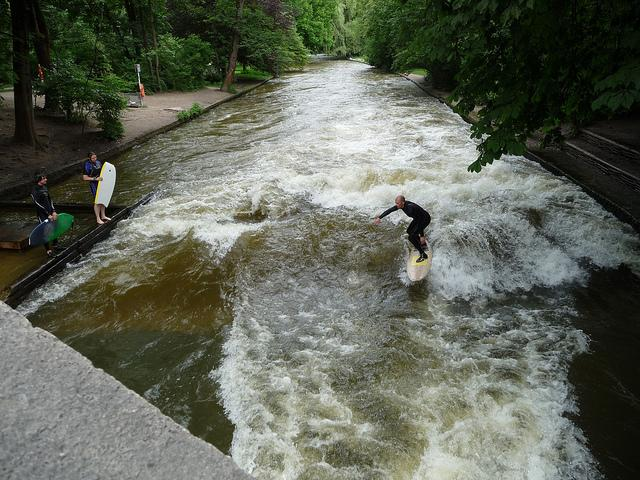Tidal bores surfing can be played on which water? Please explain your reasoning. river. This is being done on a fast-moving body of water that is longer than it is wide and runs through a forest. 